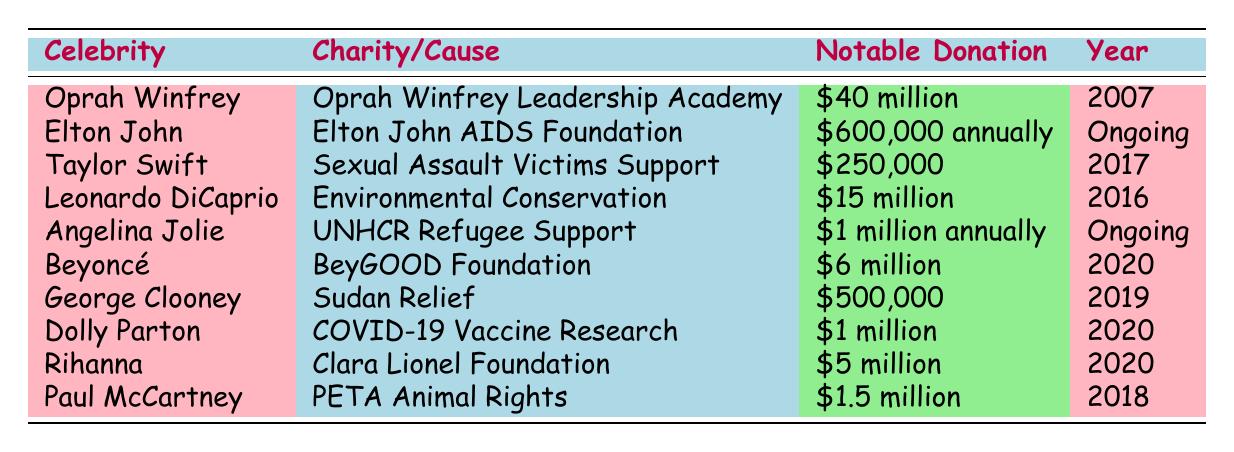What is the total amount donated by Oprah Winfrey? In the table, Oprah Winfrey's notable donation is listed as $40 million. Since this is a direct retrieval question asking for a specific value, the answer is simply that figure.
Answer: $40 million Which charity does Paul McCartney support? Referring to the table, Paul McCartney is associated with PETA Animal Rights as indicated in the charity/cause column. Hence, the answer is directly from that entry.
Answer: PETA Animal Rights Is George Clooney’s donation for Sudan Relief a one-time donation? The table shows that George Clooney made a notable donation of $500,000 in 2019. Since there is no indication of it being an ongoing annual contribution, the answer is that it is not described as such.
Answer: No What is the average amount donated by celebrities who support ongoing causes? The ongoing donations listed are by Elton John ($600,000 annually) and Angelina Jolie ($1 million annually). To find the average, add $600,000 + $1,000,000 = $1,600,000 and divide by 2, which gives $800,000. Thus, the average annual amount donated for ongoing causes is calculated.
Answer: $800,000 Did Taylor Swift donate to a cause related to health? Looking at the table, Taylor Swift donated $250,000 to Sexual Assault Victims Support, which does not directly relate to health issues like disease or medical needs. Therefore, the answer is no, based on the specific nature of the cause.
Answer: No How much did Beyoncé donate compared to the total donation of Rihanna and Dolly Parton combined? Beyoncé's donation is $6 million. For Rihanna, it’s $5 million, and for Dolly Parton, it’s $1 million. Adding those together gives $5 million + $1 million = $6 million. Since Beyoncé's donation equals this total, the comparison indicates they are equal.
Answer: Equal What year did Leonardo DiCaprio make his donation? The table shows that Leonardo DiCaprio made a notable donation in 2016 as stated clearly under the year column. Therefore, this information can be directly retrieved.
Answer: 2016 Which celebrity has the highest total charitable contribution in the year specified? The table indicates that Oprah Winfrey has the highest notable donation recorded at $40 million in 2007. Since no other entries exceed this amount based on the years listed, she holds the record for the highest total so far.
Answer: Oprah Winfrey 